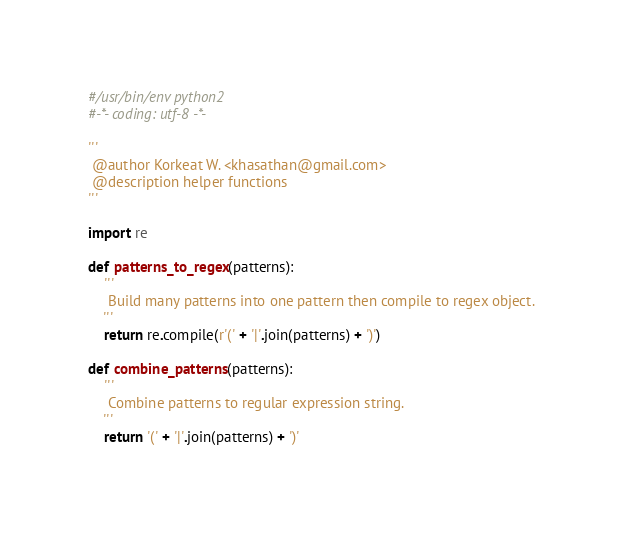Convert code to text. <code><loc_0><loc_0><loc_500><loc_500><_Python_>#/usr/bin/env python2
#-*- coding: utf-8 -*-

'''
 @author Korkeat W. <khasathan@gmail.com>
 @description helper functions
'''

import re

def patterns_to_regex(patterns):
    '''
     Build many patterns into one pattern then compile to regex object.
    '''
    return re.compile(r'(' + '|'.join(patterns) + ')')

def combine_patterns(patterns):
    '''
     Combine patterns to regular expression string.
    '''
    return '(' + '|'.join(patterns) + ')'
</code> 